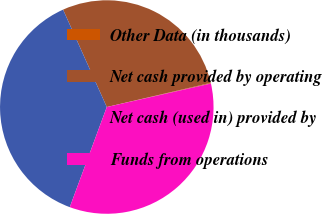Convert chart. <chart><loc_0><loc_0><loc_500><loc_500><pie_chart><fcel>Other Data (in thousands)<fcel>Net cash provided by operating<fcel>Net cash (used in) provided by<fcel>Funds from operations<nl><fcel>0.1%<fcel>28.08%<fcel>37.65%<fcel>34.17%<nl></chart> 